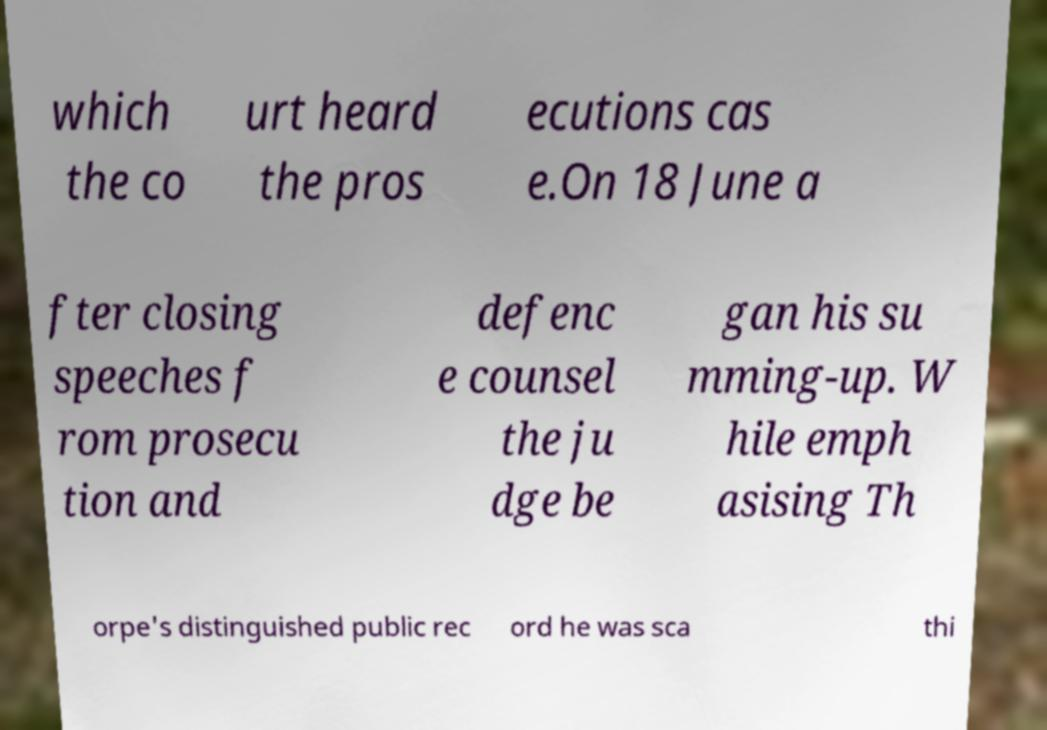For documentation purposes, I need the text within this image transcribed. Could you provide that? which the co urt heard the pros ecutions cas e.On 18 June a fter closing speeches f rom prosecu tion and defenc e counsel the ju dge be gan his su mming-up. W hile emph asising Th orpe's distinguished public rec ord he was sca thi 